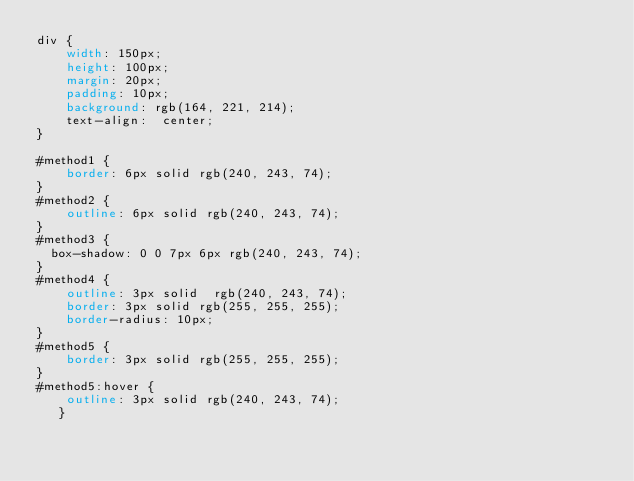Convert code to text. <code><loc_0><loc_0><loc_500><loc_500><_CSS_>div {
    width: 150px;
    height: 100px;
    margin: 20px;
    padding: 10px;
    background: rgb(164, 221, 214);
    text-align:  center;
}

#method1 {
    border: 6px solid rgb(240, 243, 74); 
}
#method2 {
    outline: 6px solid rgb(240, 243, 74); 
}
#method3 {
	box-shadow: 0 0 7px 6px rgb(240, 243, 74);
}
#method4 {
    outline: 3px solid  rgb(240, 243, 74); 
    border: 3px solid rgb(255, 255, 255); 
    border-radius: 10px; 
}
#method5 {
    border: 3px solid rgb(255, 255, 255); 
}
#method5:hover {
    outline: 3px solid rgb(240, 243, 74);
   }</code> 